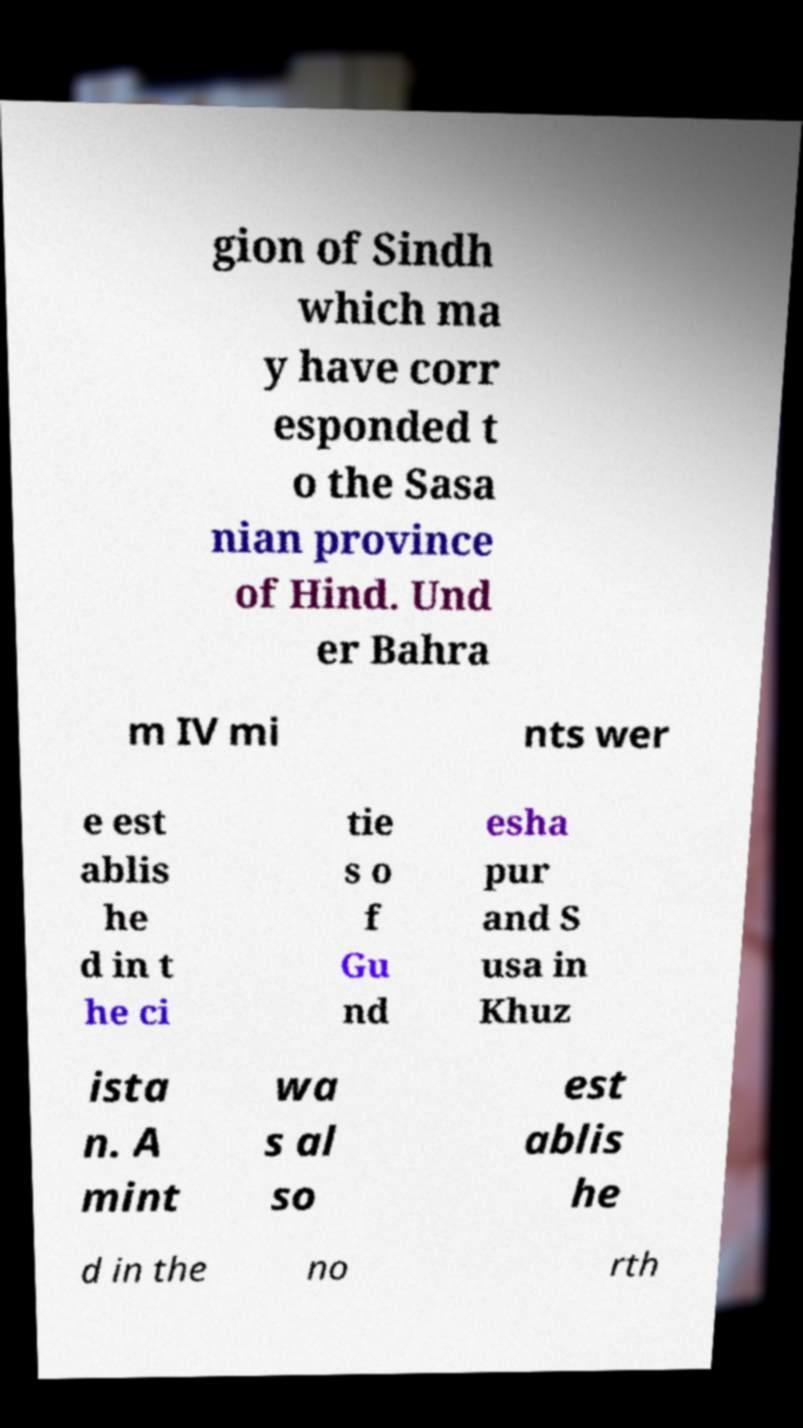Could you assist in decoding the text presented in this image and type it out clearly? gion of Sindh which ma y have corr esponded t o the Sasa nian province of Hind. Und er Bahra m IV mi nts wer e est ablis he d in t he ci tie s o f Gu nd esha pur and S usa in Khuz ista n. A mint wa s al so est ablis he d in the no rth 